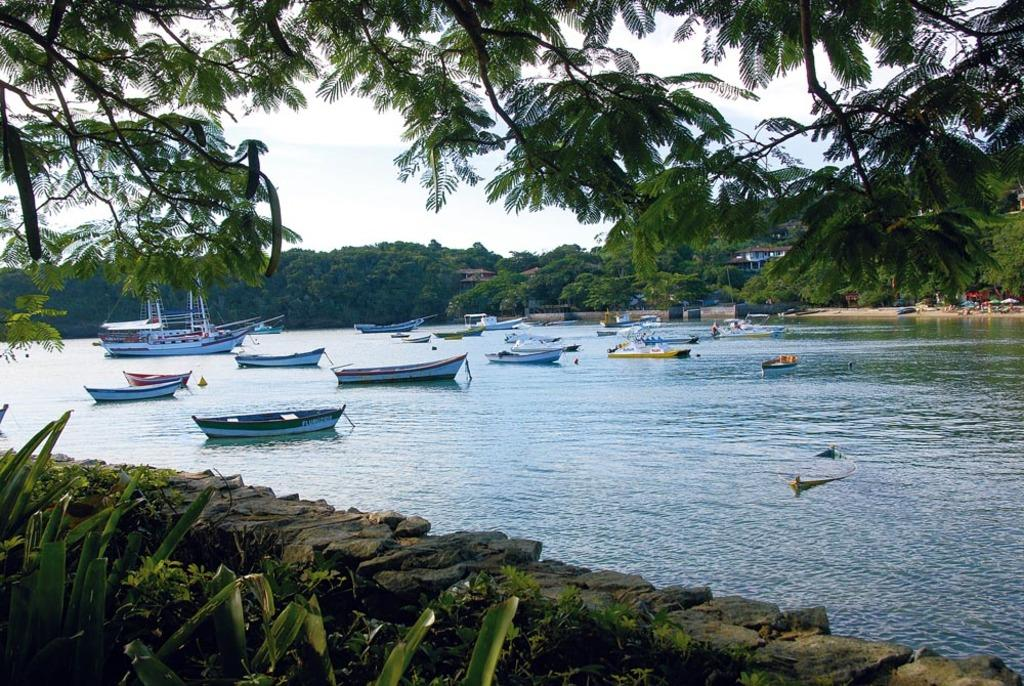What elements form a boundary at the bottom side of the image? Plants and stones form a boundary at the bottom side of the image. What is the purpose of the blood visible in the image? There is no blood visible in the image. How many folds can be seen in the umbrellas in the image? The image does not provide enough detail to determine the number of folds in the umbrellas. 